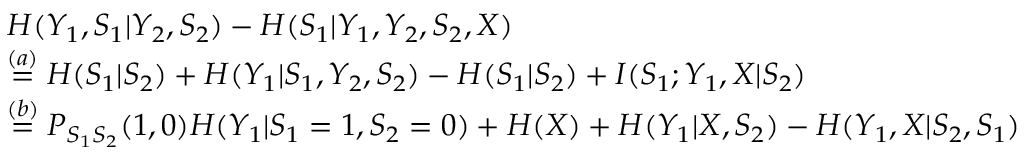Convert formula to latex. <formula><loc_0><loc_0><loc_500><loc_500>\begin{array} { r l } & { H ( Y _ { 1 } , S _ { 1 } | Y _ { 2 } , S _ { 2 } ) - H ( S _ { 1 } | Y _ { 1 } , Y _ { 2 } , S _ { 2 } , X ) } \\ & { \overset { ( a ) } { = } H ( S _ { 1 } | S _ { 2 } ) + H ( Y _ { 1 } | S _ { 1 } , Y _ { 2 } , S _ { 2 } ) - H ( S _ { 1 } | S _ { 2 } ) + I ( S _ { 1 } ; Y _ { 1 } , X | S _ { 2 } ) } \\ & { \overset { ( b ) } { = } P _ { S _ { 1 } S _ { 2 } } ( 1 , 0 ) H ( Y _ { 1 } | S _ { 1 } = 1 , S _ { 2 } = 0 ) + H ( X ) + H ( Y _ { 1 } | X , S _ { 2 } ) - H ( Y _ { 1 } , X | S _ { 2 } , S _ { 1 } ) } \end{array}</formula> 